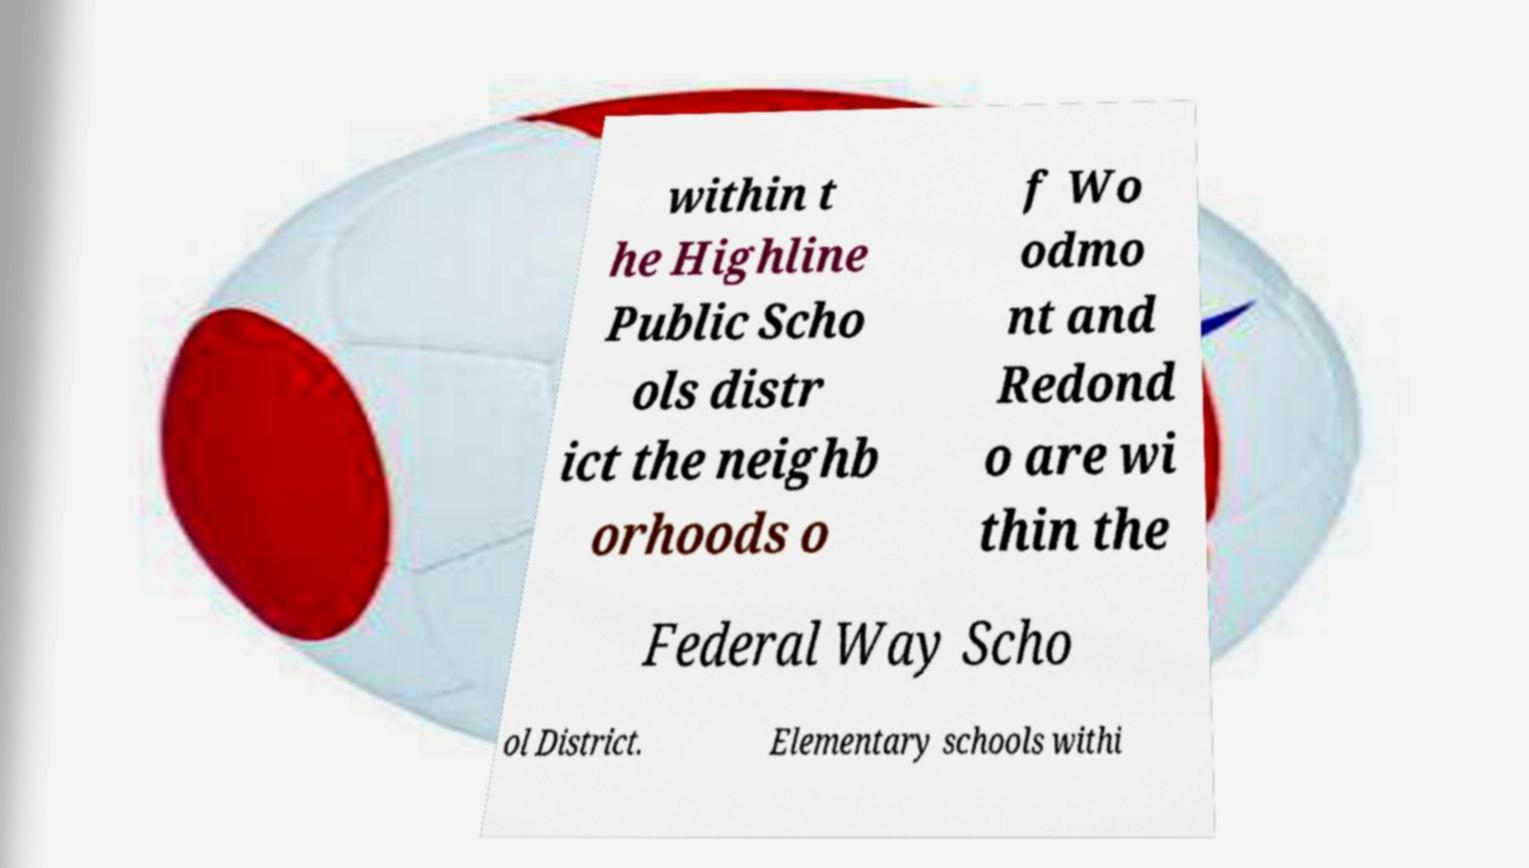For documentation purposes, I need the text within this image transcribed. Could you provide that? within t he Highline Public Scho ols distr ict the neighb orhoods o f Wo odmo nt and Redond o are wi thin the Federal Way Scho ol District. Elementary schools withi 